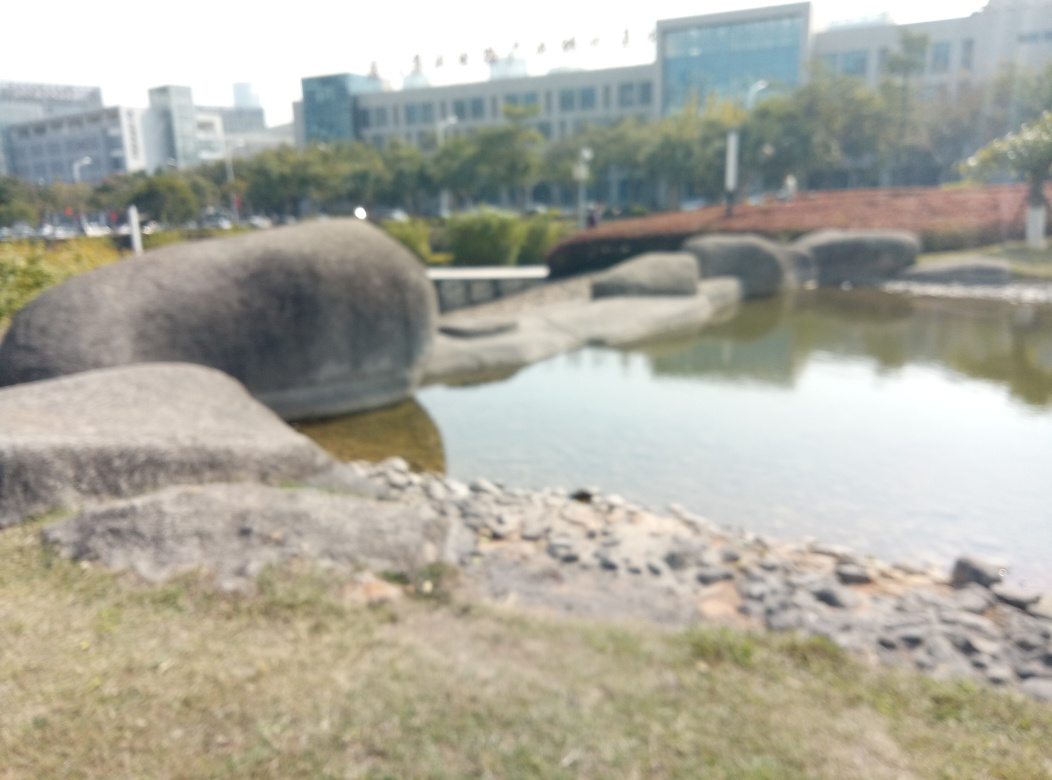What happened to the texture details of the image? The texture details of the image appear to be lost due to blurring, likely from an out-of-focus camera or a deliberate artistic choice to give an impressionist effect. Consequently, the elements such as rocks, water, and the landscape lack sharpness, making it challenging to discern fine details. 